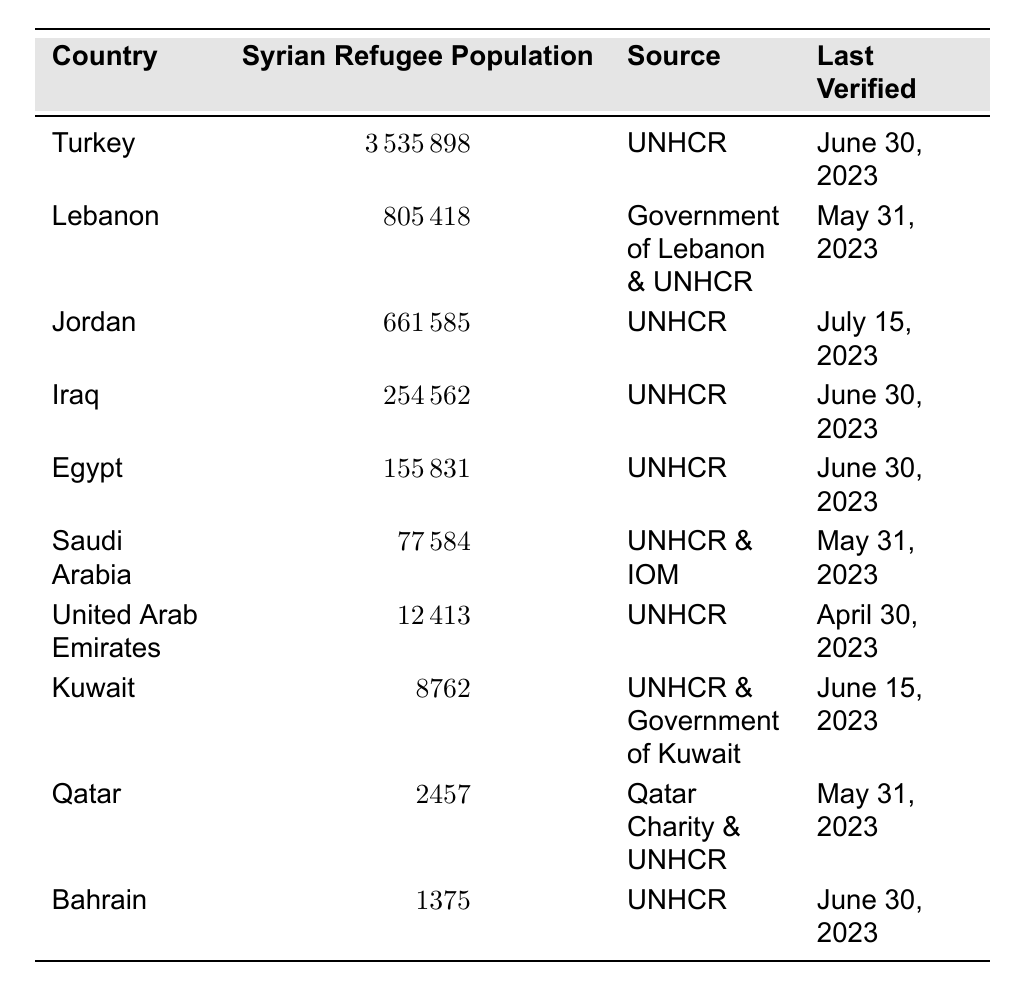What is the Syrian refugee population in Turkey? The table lists Turkey's Syrian refugee population as 3,535,898.
Answer: 3,535,898 Which country has the lowest Syrian refugee population? Bahrain is listed in the table with the lowest Syrian refugee population of 1,375.
Answer: 1,375 What is the total number of Syrian refugees in Lebanon and Jordan? The populations in Lebanon (805,418) and Jordan (661,585) sum to 1,467,003 (805,418 + 661,585 = 1,467,003).
Answer: 1,467,003 How many more Syrian refugees are there in Turkey than in Iraq? Turkey has 3,535,898 refugees while Iraq has 254,562; the difference is 3,535,898 - 254,562 = 3,281,336.
Answer: 3,281,336 What is the average number of Syrian refugees in the Gulf countries listed (Saudi Arabia, UAE, Kuwait, Qatar, Bahrain)? The populations are 77,584 (Saudi Arabia), 12,413 (UAE), 8,762 (Kuwait), 2,457 (Qatar), and 1,375 (Bahrain), summing them gives 102,591. Dividing by 5 gives an average of 20,518.2.
Answer: 20,518 Is the Syrian refugee population in Jordan higher than that in Egypt? Jordan has 661,585 refugees, whereas Egypt has 155,831; thus, Jordan's population is significantly higher.
Answer: Yes Which sources verified the refugee populations in Lebanon and Kuwait? Both Lebanon's population is verified by the "Government of Lebanon & UNHCR" while Kuwait's is verified by "UNHCR & Government of Kuwait."
Answer: Government of Lebanon & UNHCR; UNHCR & Government of Kuwait What percentage of the total Syrian refugee population, as per the table, is in Turkey? The total refugee population is the sum of all listed populations = 5,531,935. Turkey's population (3,535,898) constitutes about 63.9% (3,535,898 / 5,531,935 * 100).
Answer: 63.9% Are there more Syrian refugees in Egypt than in Qatar? Egypt has 155,831 refugees while Qatar has only 2,457. Therefore, there are indeed more refugees in Egypt.
Answer: Yes If the numbers were to remain constant, how many Syrian refugees would be expected in these neighboring countries by June 2024 based only on the latest check dates? The latest verified dates suggest no population decreases, thus the numbers would remain the same as there are no trends indicating changes.
Answer: Same numbers 